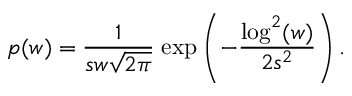Convert formula to latex. <formula><loc_0><loc_0><loc_500><loc_500>p ( w ) = \frac { 1 } { s w \sqrt { 2 \pi } } \, e x p \left ( - \frac { \log ^ { 2 } ( w ) } { 2 s ^ { 2 } } \right ) .</formula> 